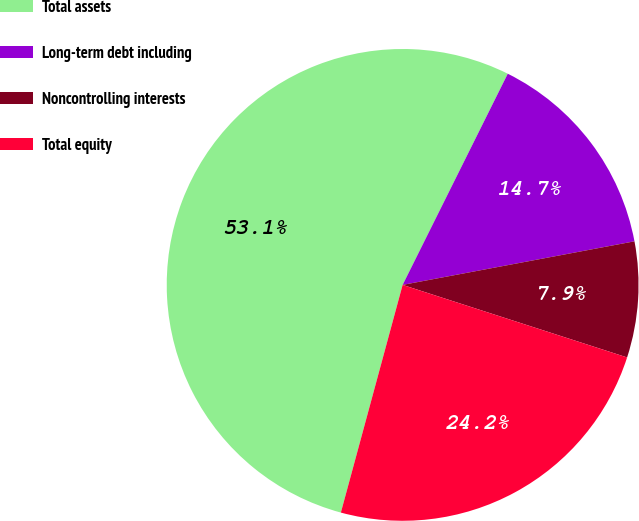Convert chart to OTSL. <chart><loc_0><loc_0><loc_500><loc_500><pie_chart><fcel>Total assets<fcel>Long-term debt including<fcel>Noncontrolling interests<fcel>Total equity<nl><fcel>53.13%<fcel>14.69%<fcel>7.93%<fcel>24.24%<nl></chart> 